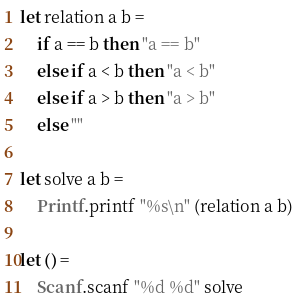<code> <loc_0><loc_0><loc_500><loc_500><_OCaml_>let relation a b =
    if a == b then "a == b"
    else if a < b then "a < b"
    else if a > b then "a > b"
    else ""

let solve a b =
    Printf.printf "%s\n" (relation a b)

let () =
    Scanf.scanf "%d %d" solve</code> 